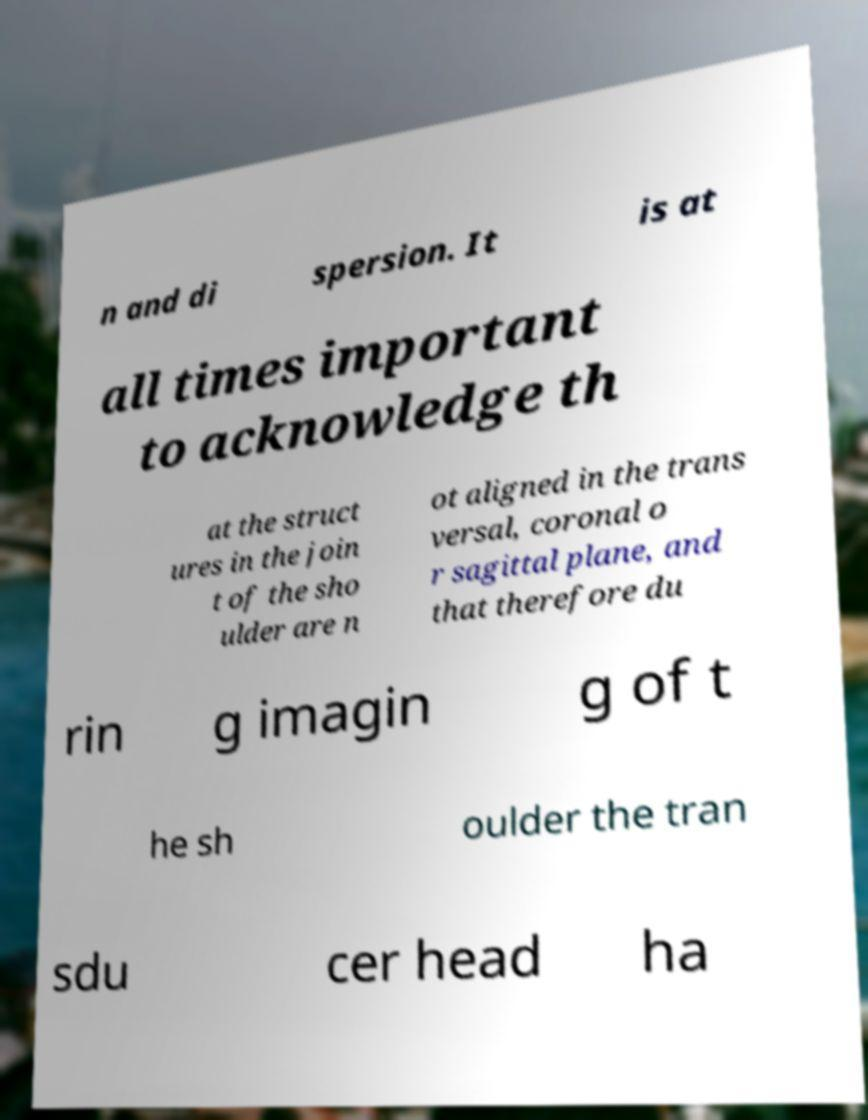Please identify and transcribe the text found in this image. n and di spersion. It is at all times important to acknowledge th at the struct ures in the join t of the sho ulder are n ot aligned in the trans versal, coronal o r sagittal plane, and that therefore du rin g imagin g of t he sh oulder the tran sdu cer head ha 